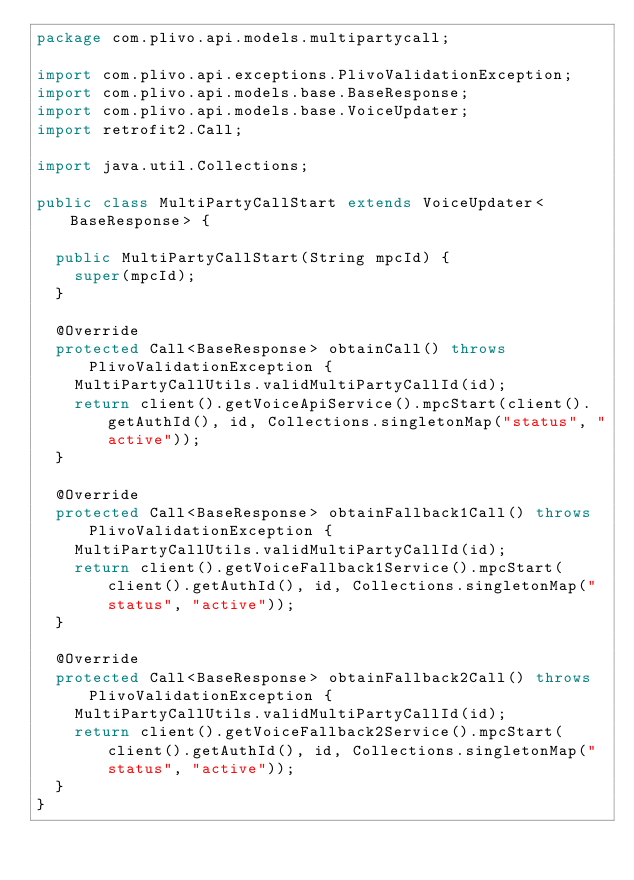<code> <loc_0><loc_0><loc_500><loc_500><_Java_>package com.plivo.api.models.multipartycall;

import com.plivo.api.exceptions.PlivoValidationException;
import com.plivo.api.models.base.BaseResponse;
import com.plivo.api.models.base.VoiceUpdater;
import retrofit2.Call;

import java.util.Collections;

public class MultiPartyCallStart extends VoiceUpdater<BaseResponse> {

  public MultiPartyCallStart(String mpcId) {
    super(mpcId);
  }

  @Override
  protected Call<BaseResponse> obtainCall() throws PlivoValidationException {
    MultiPartyCallUtils.validMultiPartyCallId(id);
    return client().getVoiceApiService().mpcStart(client().getAuthId(), id, Collections.singletonMap("status", "active"));
  }

  @Override
  protected Call<BaseResponse> obtainFallback1Call() throws PlivoValidationException {
    MultiPartyCallUtils.validMultiPartyCallId(id);
    return client().getVoiceFallback1Service().mpcStart(client().getAuthId(), id, Collections.singletonMap("status", "active"));
  }

  @Override
  protected Call<BaseResponse> obtainFallback2Call() throws PlivoValidationException {
    MultiPartyCallUtils.validMultiPartyCallId(id);
    return client().getVoiceFallback2Service().mpcStart(client().getAuthId(), id, Collections.singletonMap("status", "active"));
  }
}</code> 